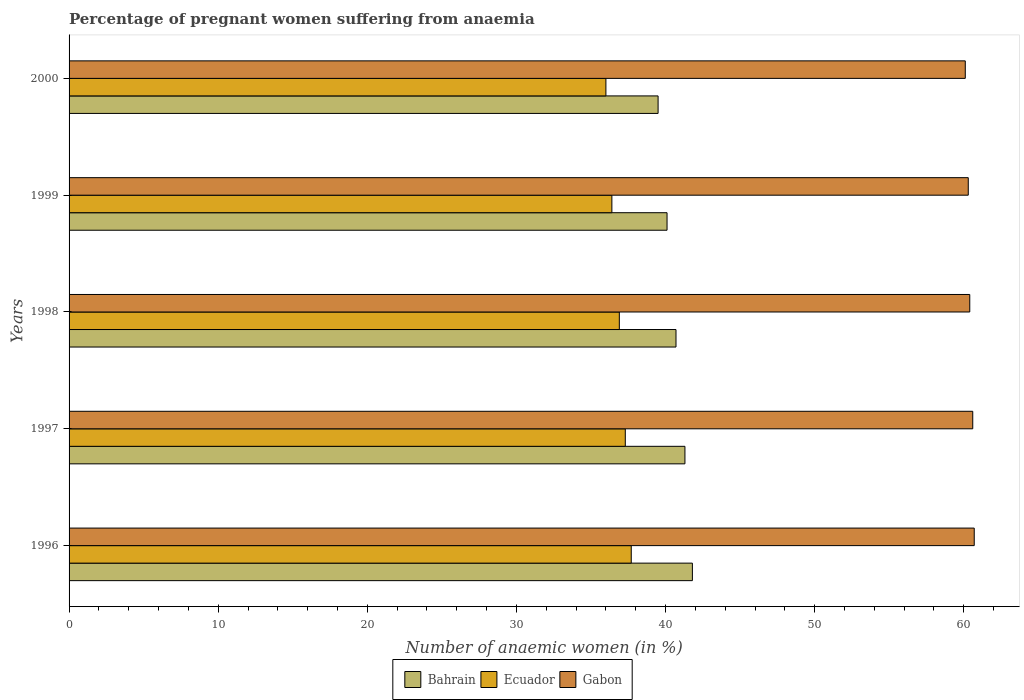Are the number of bars on each tick of the Y-axis equal?
Offer a terse response. Yes. How many bars are there on the 3rd tick from the top?
Your response must be concise. 3. What is the label of the 5th group of bars from the top?
Your response must be concise. 1996. What is the number of anaemic women in Bahrain in 1998?
Offer a very short reply. 40.7. Across all years, what is the maximum number of anaemic women in Ecuador?
Provide a succinct answer. 37.7. Across all years, what is the minimum number of anaemic women in Bahrain?
Your answer should be very brief. 39.5. In which year was the number of anaemic women in Ecuador minimum?
Offer a very short reply. 2000. What is the total number of anaemic women in Ecuador in the graph?
Give a very brief answer. 184.3. What is the difference between the number of anaemic women in Gabon in 1996 and that in 2000?
Your response must be concise. 0.6. What is the difference between the number of anaemic women in Gabon in 1996 and the number of anaemic women in Bahrain in 2000?
Keep it short and to the point. 21.2. What is the average number of anaemic women in Gabon per year?
Your answer should be compact. 60.42. In the year 1996, what is the difference between the number of anaemic women in Gabon and number of anaemic women in Bahrain?
Provide a succinct answer. 18.9. In how many years, is the number of anaemic women in Ecuador greater than 32 %?
Ensure brevity in your answer.  5. What is the ratio of the number of anaemic women in Gabon in 1996 to that in 1997?
Offer a terse response. 1. What is the difference between the highest and the second highest number of anaemic women in Ecuador?
Offer a terse response. 0.4. What is the difference between the highest and the lowest number of anaemic women in Ecuador?
Provide a succinct answer. 1.7. In how many years, is the number of anaemic women in Bahrain greater than the average number of anaemic women in Bahrain taken over all years?
Provide a succinct answer. 3. Is the sum of the number of anaemic women in Ecuador in 1996 and 1999 greater than the maximum number of anaemic women in Bahrain across all years?
Offer a very short reply. Yes. What does the 3rd bar from the top in 1999 represents?
Keep it short and to the point. Bahrain. What does the 3rd bar from the bottom in 1996 represents?
Your answer should be compact. Gabon. Are all the bars in the graph horizontal?
Keep it short and to the point. Yes. How many years are there in the graph?
Your answer should be compact. 5. Are the values on the major ticks of X-axis written in scientific E-notation?
Provide a succinct answer. No. Does the graph contain any zero values?
Provide a succinct answer. No. Does the graph contain grids?
Provide a short and direct response. No. Where does the legend appear in the graph?
Make the answer very short. Bottom center. How many legend labels are there?
Keep it short and to the point. 3. What is the title of the graph?
Your answer should be compact. Percentage of pregnant women suffering from anaemia. Does "Samoa" appear as one of the legend labels in the graph?
Your response must be concise. No. What is the label or title of the X-axis?
Your answer should be compact. Number of anaemic women (in %). What is the Number of anaemic women (in %) of Bahrain in 1996?
Give a very brief answer. 41.8. What is the Number of anaemic women (in %) of Ecuador in 1996?
Give a very brief answer. 37.7. What is the Number of anaemic women (in %) in Gabon in 1996?
Your answer should be compact. 60.7. What is the Number of anaemic women (in %) in Bahrain in 1997?
Keep it short and to the point. 41.3. What is the Number of anaemic women (in %) in Ecuador in 1997?
Give a very brief answer. 37.3. What is the Number of anaemic women (in %) in Gabon in 1997?
Your answer should be very brief. 60.6. What is the Number of anaemic women (in %) in Bahrain in 1998?
Your answer should be compact. 40.7. What is the Number of anaemic women (in %) in Ecuador in 1998?
Keep it short and to the point. 36.9. What is the Number of anaemic women (in %) of Gabon in 1998?
Ensure brevity in your answer.  60.4. What is the Number of anaemic women (in %) of Bahrain in 1999?
Provide a short and direct response. 40.1. What is the Number of anaemic women (in %) of Ecuador in 1999?
Your response must be concise. 36.4. What is the Number of anaemic women (in %) of Gabon in 1999?
Offer a terse response. 60.3. What is the Number of anaemic women (in %) in Bahrain in 2000?
Your response must be concise. 39.5. What is the Number of anaemic women (in %) of Gabon in 2000?
Keep it short and to the point. 60.1. Across all years, what is the maximum Number of anaemic women (in %) in Bahrain?
Keep it short and to the point. 41.8. Across all years, what is the maximum Number of anaemic women (in %) of Ecuador?
Keep it short and to the point. 37.7. Across all years, what is the maximum Number of anaemic women (in %) in Gabon?
Give a very brief answer. 60.7. Across all years, what is the minimum Number of anaemic women (in %) of Bahrain?
Your answer should be very brief. 39.5. Across all years, what is the minimum Number of anaemic women (in %) in Ecuador?
Keep it short and to the point. 36. Across all years, what is the minimum Number of anaemic women (in %) of Gabon?
Keep it short and to the point. 60.1. What is the total Number of anaemic women (in %) of Bahrain in the graph?
Provide a short and direct response. 203.4. What is the total Number of anaemic women (in %) of Ecuador in the graph?
Provide a short and direct response. 184.3. What is the total Number of anaemic women (in %) in Gabon in the graph?
Provide a short and direct response. 302.1. What is the difference between the Number of anaemic women (in %) in Bahrain in 1996 and that in 1997?
Ensure brevity in your answer.  0.5. What is the difference between the Number of anaemic women (in %) in Ecuador in 1996 and that in 1997?
Your answer should be very brief. 0.4. What is the difference between the Number of anaemic women (in %) in Gabon in 1996 and that in 1997?
Your answer should be compact. 0.1. What is the difference between the Number of anaemic women (in %) in Bahrain in 1996 and that in 1998?
Your answer should be very brief. 1.1. What is the difference between the Number of anaemic women (in %) in Bahrain in 1996 and that in 2000?
Give a very brief answer. 2.3. What is the difference between the Number of anaemic women (in %) of Ecuador in 1996 and that in 2000?
Offer a terse response. 1.7. What is the difference between the Number of anaemic women (in %) in Gabon in 1996 and that in 2000?
Your answer should be compact. 0.6. What is the difference between the Number of anaemic women (in %) in Bahrain in 1997 and that in 1998?
Ensure brevity in your answer.  0.6. What is the difference between the Number of anaemic women (in %) in Bahrain in 1997 and that in 1999?
Make the answer very short. 1.2. What is the difference between the Number of anaemic women (in %) of Ecuador in 1997 and that in 1999?
Your response must be concise. 0.9. What is the difference between the Number of anaemic women (in %) in Bahrain in 1997 and that in 2000?
Your response must be concise. 1.8. What is the difference between the Number of anaemic women (in %) of Ecuador in 1997 and that in 2000?
Offer a terse response. 1.3. What is the difference between the Number of anaemic women (in %) in Gabon in 1997 and that in 2000?
Your response must be concise. 0.5. What is the difference between the Number of anaemic women (in %) of Gabon in 1998 and that in 2000?
Offer a very short reply. 0.3. What is the difference between the Number of anaemic women (in %) in Bahrain in 1999 and that in 2000?
Your response must be concise. 0.6. What is the difference between the Number of anaemic women (in %) in Bahrain in 1996 and the Number of anaemic women (in %) in Ecuador in 1997?
Your answer should be compact. 4.5. What is the difference between the Number of anaemic women (in %) of Bahrain in 1996 and the Number of anaemic women (in %) of Gabon in 1997?
Keep it short and to the point. -18.8. What is the difference between the Number of anaemic women (in %) in Ecuador in 1996 and the Number of anaemic women (in %) in Gabon in 1997?
Offer a very short reply. -22.9. What is the difference between the Number of anaemic women (in %) of Bahrain in 1996 and the Number of anaemic women (in %) of Ecuador in 1998?
Provide a short and direct response. 4.9. What is the difference between the Number of anaemic women (in %) in Bahrain in 1996 and the Number of anaemic women (in %) in Gabon in 1998?
Provide a short and direct response. -18.6. What is the difference between the Number of anaemic women (in %) in Ecuador in 1996 and the Number of anaemic women (in %) in Gabon in 1998?
Your response must be concise. -22.7. What is the difference between the Number of anaemic women (in %) in Bahrain in 1996 and the Number of anaemic women (in %) in Gabon in 1999?
Your answer should be compact. -18.5. What is the difference between the Number of anaemic women (in %) of Ecuador in 1996 and the Number of anaemic women (in %) of Gabon in 1999?
Make the answer very short. -22.6. What is the difference between the Number of anaemic women (in %) of Bahrain in 1996 and the Number of anaemic women (in %) of Ecuador in 2000?
Your answer should be very brief. 5.8. What is the difference between the Number of anaemic women (in %) in Bahrain in 1996 and the Number of anaemic women (in %) in Gabon in 2000?
Offer a very short reply. -18.3. What is the difference between the Number of anaemic women (in %) in Ecuador in 1996 and the Number of anaemic women (in %) in Gabon in 2000?
Give a very brief answer. -22.4. What is the difference between the Number of anaemic women (in %) of Bahrain in 1997 and the Number of anaemic women (in %) of Ecuador in 1998?
Your answer should be compact. 4.4. What is the difference between the Number of anaemic women (in %) of Bahrain in 1997 and the Number of anaemic women (in %) of Gabon in 1998?
Keep it short and to the point. -19.1. What is the difference between the Number of anaemic women (in %) in Ecuador in 1997 and the Number of anaemic women (in %) in Gabon in 1998?
Offer a terse response. -23.1. What is the difference between the Number of anaemic women (in %) of Bahrain in 1997 and the Number of anaemic women (in %) of Gabon in 1999?
Your answer should be compact. -19. What is the difference between the Number of anaemic women (in %) of Ecuador in 1997 and the Number of anaemic women (in %) of Gabon in 1999?
Offer a very short reply. -23. What is the difference between the Number of anaemic women (in %) in Bahrain in 1997 and the Number of anaemic women (in %) in Gabon in 2000?
Ensure brevity in your answer.  -18.8. What is the difference between the Number of anaemic women (in %) of Ecuador in 1997 and the Number of anaemic women (in %) of Gabon in 2000?
Provide a short and direct response. -22.8. What is the difference between the Number of anaemic women (in %) of Bahrain in 1998 and the Number of anaemic women (in %) of Gabon in 1999?
Provide a succinct answer. -19.6. What is the difference between the Number of anaemic women (in %) in Ecuador in 1998 and the Number of anaemic women (in %) in Gabon in 1999?
Provide a succinct answer. -23.4. What is the difference between the Number of anaemic women (in %) in Bahrain in 1998 and the Number of anaemic women (in %) in Ecuador in 2000?
Ensure brevity in your answer.  4.7. What is the difference between the Number of anaemic women (in %) of Bahrain in 1998 and the Number of anaemic women (in %) of Gabon in 2000?
Keep it short and to the point. -19.4. What is the difference between the Number of anaemic women (in %) in Ecuador in 1998 and the Number of anaemic women (in %) in Gabon in 2000?
Provide a short and direct response. -23.2. What is the difference between the Number of anaemic women (in %) in Bahrain in 1999 and the Number of anaemic women (in %) in Gabon in 2000?
Provide a short and direct response. -20. What is the difference between the Number of anaemic women (in %) in Ecuador in 1999 and the Number of anaemic women (in %) in Gabon in 2000?
Provide a succinct answer. -23.7. What is the average Number of anaemic women (in %) in Bahrain per year?
Give a very brief answer. 40.68. What is the average Number of anaemic women (in %) in Ecuador per year?
Give a very brief answer. 36.86. What is the average Number of anaemic women (in %) in Gabon per year?
Give a very brief answer. 60.42. In the year 1996, what is the difference between the Number of anaemic women (in %) of Bahrain and Number of anaemic women (in %) of Ecuador?
Offer a terse response. 4.1. In the year 1996, what is the difference between the Number of anaemic women (in %) of Bahrain and Number of anaemic women (in %) of Gabon?
Your response must be concise. -18.9. In the year 1996, what is the difference between the Number of anaemic women (in %) in Ecuador and Number of anaemic women (in %) in Gabon?
Keep it short and to the point. -23. In the year 1997, what is the difference between the Number of anaemic women (in %) of Bahrain and Number of anaemic women (in %) of Gabon?
Your response must be concise. -19.3. In the year 1997, what is the difference between the Number of anaemic women (in %) in Ecuador and Number of anaemic women (in %) in Gabon?
Make the answer very short. -23.3. In the year 1998, what is the difference between the Number of anaemic women (in %) of Bahrain and Number of anaemic women (in %) of Gabon?
Provide a short and direct response. -19.7. In the year 1998, what is the difference between the Number of anaemic women (in %) of Ecuador and Number of anaemic women (in %) of Gabon?
Provide a short and direct response. -23.5. In the year 1999, what is the difference between the Number of anaemic women (in %) of Bahrain and Number of anaemic women (in %) of Gabon?
Keep it short and to the point. -20.2. In the year 1999, what is the difference between the Number of anaemic women (in %) in Ecuador and Number of anaemic women (in %) in Gabon?
Give a very brief answer. -23.9. In the year 2000, what is the difference between the Number of anaemic women (in %) in Bahrain and Number of anaemic women (in %) in Gabon?
Your response must be concise. -20.6. In the year 2000, what is the difference between the Number of anaemic women (in %) in Ecuador and Number of anaemic women (in %) in Gabon?
Provide a short and direct response. -24.1. What is the ratio of the Number of anaemic women (in %) of Bahrain in 1996 to that in 1997?
Your answer should be compact. 1.01. What is the ratio of the Number of anaemic women (in %) of Ecuador in 1996 to that in 1997?
Your answer should be compact. 1.01. What is the ratio of the Number of anaemic women (in %) of Ecuador in 1996 to that in 1998?
Your answer should be compact. 1.02. What is the ratio of the Number of anaemic women (in %) of Gabon in 1996 to that in 1998?
Provide a short and direct response. 1. What is the ratio of the Number of anaemic women (in %) in Bahrain in 1996 to that in 1999?
Ensure brevity in your answer.  1.04. What is the ratio of the Number of anaemic women (in %) of Ecuador in 1996 to that in 1999?
Make the answer very short. 1.04. What is the ratio of the Number of anaemic women (in %) in Gabon in 1996 to that in 1999?
Ensure brevity in your answer.  1.01. What is the ratio of the Number of anaemic women (in %) of Bahrain in 1996 to that in 2000?
Your answer should be very brief. 1.06. What is the ratio of the Number of anaemic women (in %) in Ecuador in 1996 to that in 2000?
Your answer should be very brief. 1.05. What is the ratio of the Number of anaemic women (in %) in Bahrain in 1997 to that in 1998?
Make the answer very short. 1.01. What is the ratio of the Number of anaemic women (in %) of Ecuador in 1997 to that in 1998?
Make the answer very short. 1.01. What is the ratio of the Number of anaemic women (in %) in Gabon in 1997 to that in 1998?
Give a very brief answer. 1. What is the ratio of the Number of anaemic women (in %) in Bahrain in 1997 to that in 1999?
Make the answer very short. 1.03. What is the ratio of the Number of anaemic women (in %) in Ecuador in 1997 to that in 1999?
Give a very brief answer. 1.02. What is the ratio of the Number of anaemic women (in %) in Gabon in 1997 to that in 1999?
Offer a terse response. 1. What is the ratio of the Number of anaemic women (in %) in Bahrain in 1997 to that in 2000?
Offer a very short reply. 1.05. What is the ratio of the Number of anaemic women (in %) of Ecuador in 1997 to that in 2000?
Provide a succinct answer. 1.04. What is the ratio of the Number of anaemic women (in %) in Gabon in 1997 to that in 2000?
Offer a very short reply. 1.01. What is the ratio of the Number of anaemic women (in %) of Bahrain in 1998 to that in 1999?
Offer a terse response. 1.01. What is the ratio of the Number of anaemic women (in %) in Ecuador in 1998 to that in 1999?
Keep it short and to the point. 1.01. What is the ratio of the Number of anaemic women (in %) in Gabon in 1998 to that in 1999?
Keep it short and to the point. 1. What is the ratio of the Number of anaemic women (in %) in Bahrain in 1998 to that in 2000?
Ensure brevity in your answer.  1.03. What is the ratio of the Number of anaemic women (in %) in Ecuador in 1998 to that in 2000?
Your answer should be very brief. 1.02. What is the ratio of the Number of anaemic women (in %) in Gabon in 1998 to that in 2000?
Your answer should be compact. 1. What is the ratio of the Number of anaemic women (in %) of Bahrain in 1999 to that in 2000?
Your answer should be very brief. 1.02. What is the ratio of the Number of anaemic women (in %) of Ecuador in 1999 to that in 2000?
Give a very brief answer. 1.01. What is the difference between the highest and the second highest Number of anaemic women (in %) of Ecuador?
Your answer should be very brief. 0.4. What is the difference between the highest and the lowest Number of anaemic women (in %) in Gabon?
Your response must be concise. 0.6. 